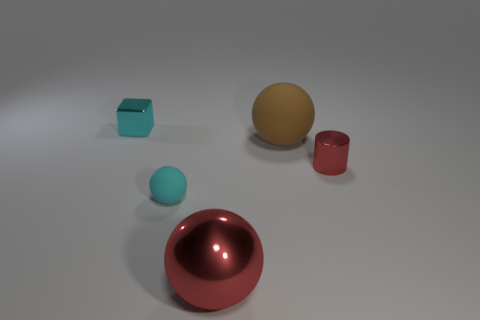There is a large thing that is the same material as the tiny cyan block; what shape is it?
Offer a very short reply. Sphere. Is the tiny cube made of the same material as the tiny cyan object that is in front of the red metal cylinder?
Provide a succinct answer. No. Are there any small objects in front of the sphere that is behind the tiny cyan matte sphere?
Your answer should be compact. Yes. What material is the large brown object that is the same shape as the tiny matte object?
Keep it short and to the point. Rubber. There is a metal object that is left of the large red shiny ball; how many small cyan objects are in front of it?
Provide a succinct answer. 1. Is there any other thing that has the same color as the big rubber thing?
Ensure brevity in your answer.  No. What number of objects are small green shiny balls or metal things in front of the tiny red shiny cylinder?
Your answer should be very brief. 1. What is the small cyan thing that is behind the small shiny thing that is to the right of the big object that is on the right side of the big red object made of?
Give a very brief answer. Metal. What size is the cylinder that is the same material as the cube?
Provide a succinct answer. Small. There is a large object in front of the large rubber ball in front of the metallic cube; what color is it?
Provide a succinct answer. Red. 